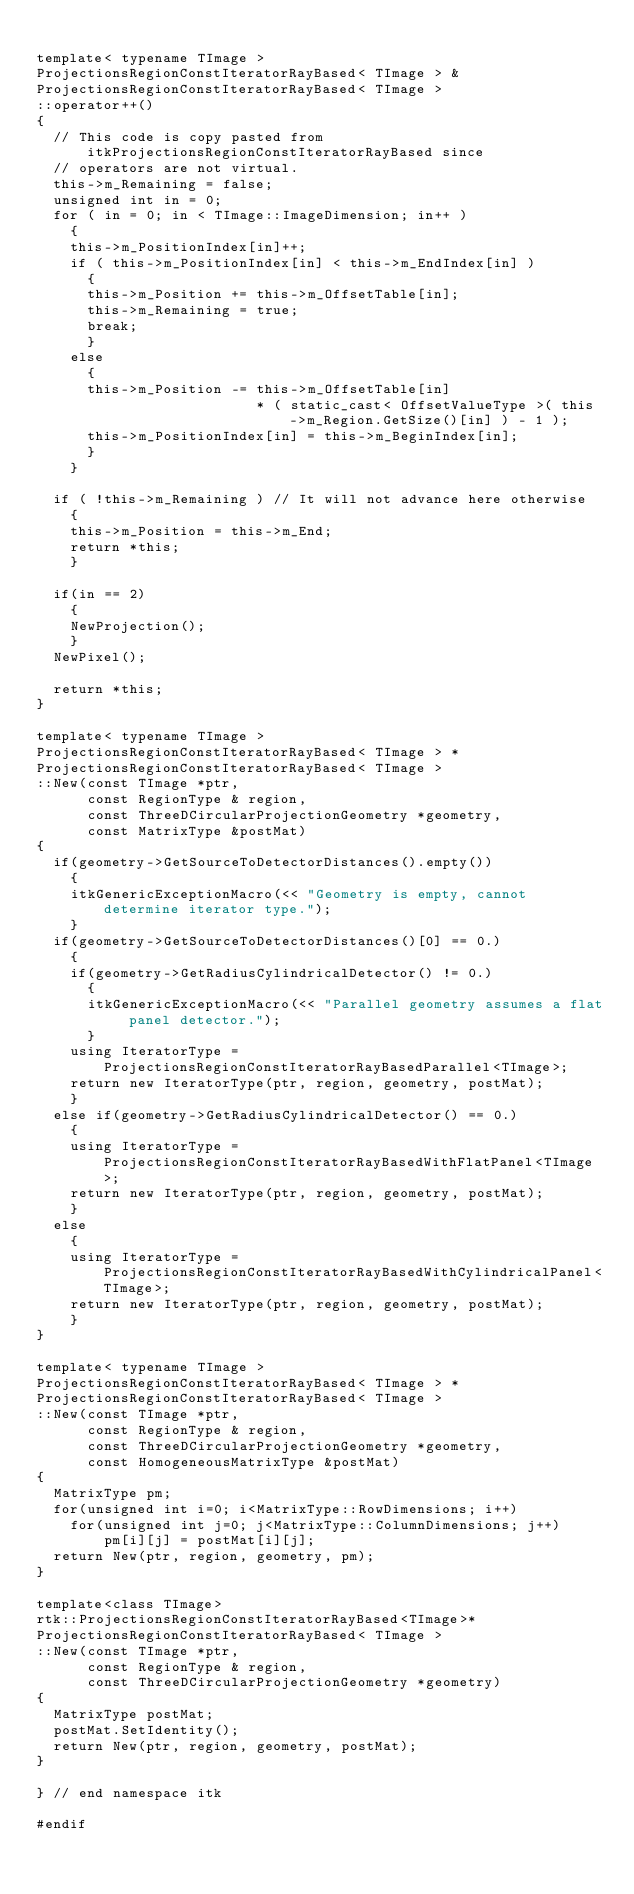<code> <loc_0><loc_0><loc_500><loc_500><_C++_>
template< typename TImage >
ProjectionsRegionConstIteratorRayBased< TImage > &
ProjectionsRegionConstIteratorRayBased< TImage >
::operator++()
{
  // This code is copy pasted from itkProjectionsRegionConstIteratorRayBased since
  // operators are not virtual.
  this->m_Remaining = false;
  unsigned int in = 0;
  for ( in = 0; in < TImage::ImageDimension; in++ )
    {
    this->m_PositionIndex[in]++;
    if ( this->m_PositionIndex[in] < this->m_EndIndex[in] )
      {
      this->m_Position += this->m_OffsetTable[in];
      this->m_Remaining = true;
      break;
      }
    else
      {
      this->m_Position -= this->m_OffsetTable[in]
                          * ( static_cast< OffsetValueType >( this->m_Region.GetSize()[in] ) - 1 );
      this->m_PositionIndex[in] = this->m_BeginIndex[in];
      }
    }

  if ( !this->m_Remaining ) // It will not advance here otherwise
    {
    this->m_Position = this->m_End;
    return *this;
    }

  if(in == 2)
    {
    NewProjection();
    }
  NewPixel();

  return *this;
}

template< typename TImage >
ProjectionsRegionConstIteratorRayBased< TImage > *
ProjectionsRegionConstIteratorRayBased< TImage >
::New(const TImage *ptr,
      const RegionType & region,
      const ThreeDCircularProjectionGeometry *geometry,
      const MatrixType &postMat)
{
  if(geometry->GetSourceToDetectorDistances().empty())
    {
    itkGenericExceptionMacro(<< "Geometry is empty, cannot determine iterator type.");
    }
  if(geometry->GetSourceToDetectorDistances()[0] == 0.)
    {
    if(geometry->GetRadiusCylindricalDetector() != 0.)
      {
      itkGenericExceptionMacro(<< "Parallel geometry assumes a flat panel detector.");
      }
    using IteratorType = ProjectionsRegionConstIteratorRayBasedParallel<TImage>;
    return new IteratorType(ptr, region, geometry, postMat);
    }
  else if(geometry->GetRadiusCylindricalDetector() == 0.)
    {
    using IteratorType = ProjectionsRegionConstIteratorRayBasedWithFlatPanel<TImage>;
    return new IteratorType(ptr, region, geometry, postMat);
    }
  else
    {
    using IteratorType = ProjectionsRegionConstIteratorRayBasedWithCylindricalPanel<TImage>;
    return new IteratorType(ptr, region, geometry, postMat);
    }
}

template< typename TImage >
ProjectionsRegionConstIteratorRayBased< TImage > *
ProjectionsRegionConstIteratorRayBased< TImage >
::New(const TImage *ptr,
      const RegionType & region,
      const ThreeDCircularProjectionGeometry *geometry,
      const HomogeneousMatrixType &postMat)
{
  MatrixType pm;
  for(unsigned int i=0; i<MatrixType::RowDimensions; i++)
    for(unsigned int j=0; j<MatrixType::ColumnDimensions; j++)
        pm[i][j] = postMat[i][j];
  return New(ptr, region, geometry, pm);
}

template<class TImage>
rtk::ProjectionsRegionConstIteratorRayBased<TImage>*
ProjectionsRegionConstIteratorRayBased< TImage >
::New(const TImage *ptr,
      const RegionType & region,
      const ThreeDCircularProjectionGeometry *geometry)
{
  MatrixType postMat;
  postMat.SetIdentity();
  return New(ptr, region, geometry, postMat);
}

} // end namespace itk

#endif
</code> 